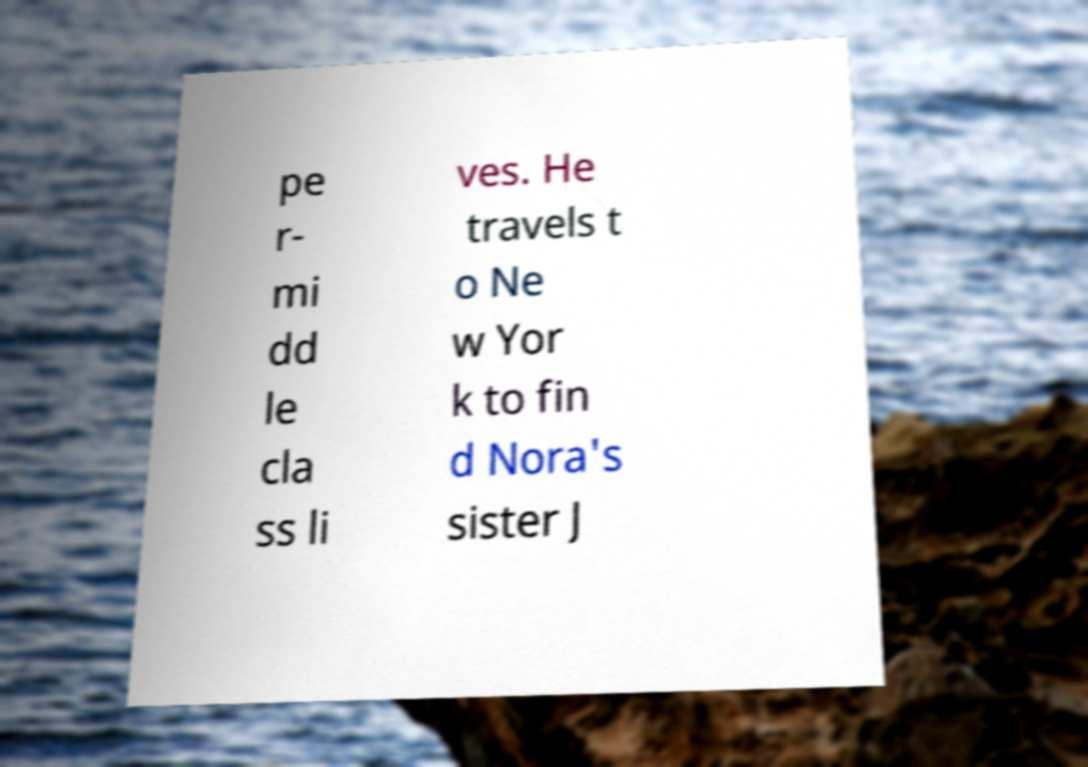For documentation purposes, I need the text within this image transcribed. Could you provide that? pe r- mi dd le cla ss li ves. He travels t o Ne w Yor k to fin d Nora's sister J 